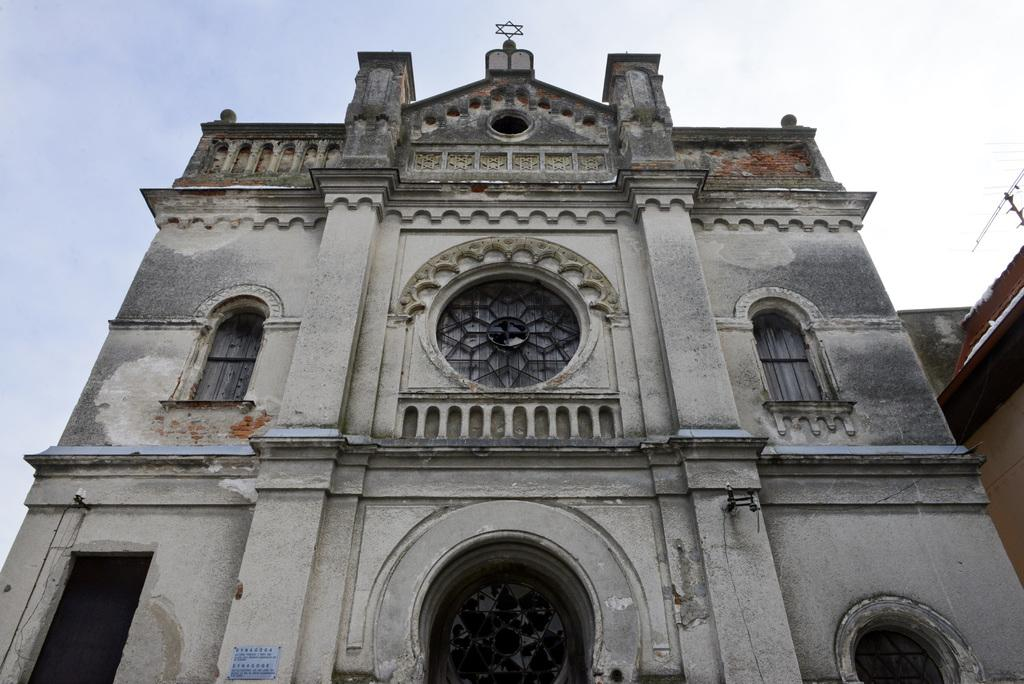What type of structures can be seen in the image? There are buildings in the image. What part of the buildings can be seen in the image? There are windows visible in the image. What is visible in the background of the image? The sky is visible in the image. What object is present in the image that might be used for displaying information? There is a board in the image. What can be seen on the board? Something is written on the board. Reasoning: Let'g: Let's think step by step in order to produce the conversation. We start by identifying the main subject in the image, which is the buildings. Then, we expand the conversation to include other details about the buildings, such as the presence of windows and the visibility of the sky. Next, we mention the board as an object that might be used for displaying information, and we describe what is written on it. Absurd Question/Answer: What type of coat is hanging on the crate in the image? There is no coat or crate present in the image. What type of system is being used to organize the information on the board? The provided facts do not mention any specific system for organizing the information on the board. 